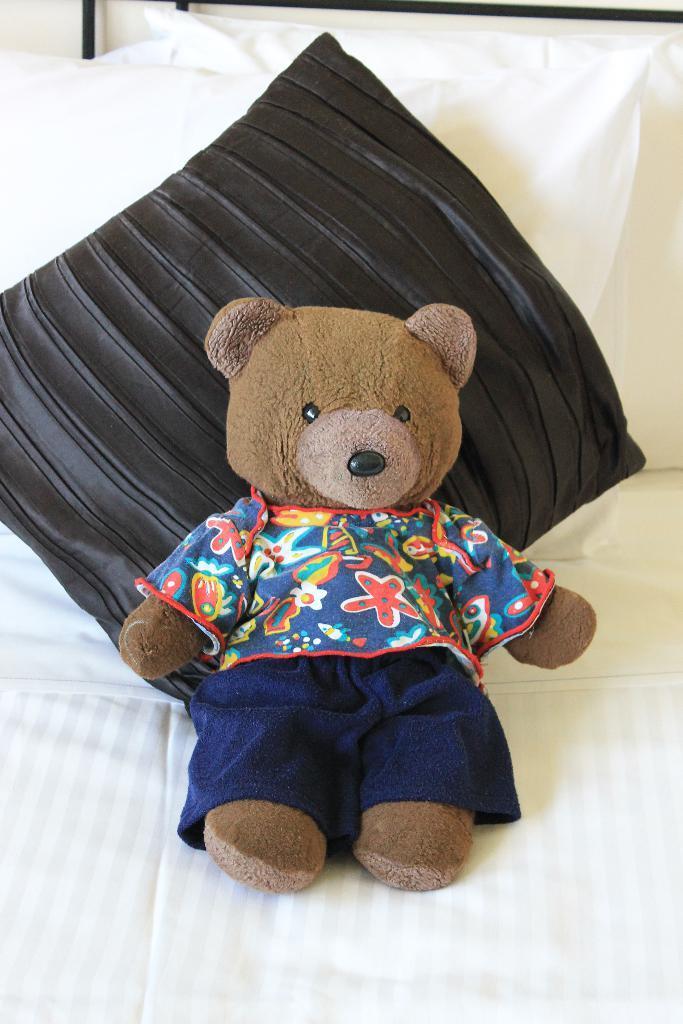Could you give a brief overview of what you see in this image? In this image we can see the doll with clothes on the bed and there are pillows and rods at the back. 